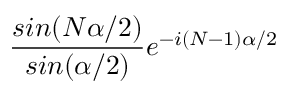Convert formula to latex. <formula><loc_0><loc_0><loc_500><loc_500>\frac { \sin ( N \alpha / 2 ) } { \sin ( \alpha / 2 ) } e ^ { - i ( N - 1 ) \alpha / 2 }</formula> 